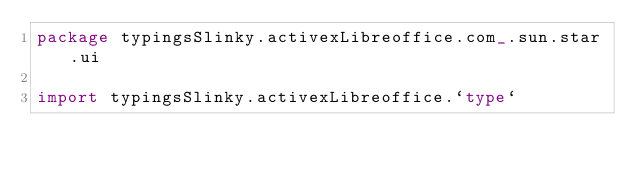Convert code to text. <code><loc_0><loc_0><loc_500><loc_500><_Scala_>package typingsSlinky.activexLibreoffice.com_.sun.star.ui

import typingsSlinky.activexLibreoffice.`type`</code> 